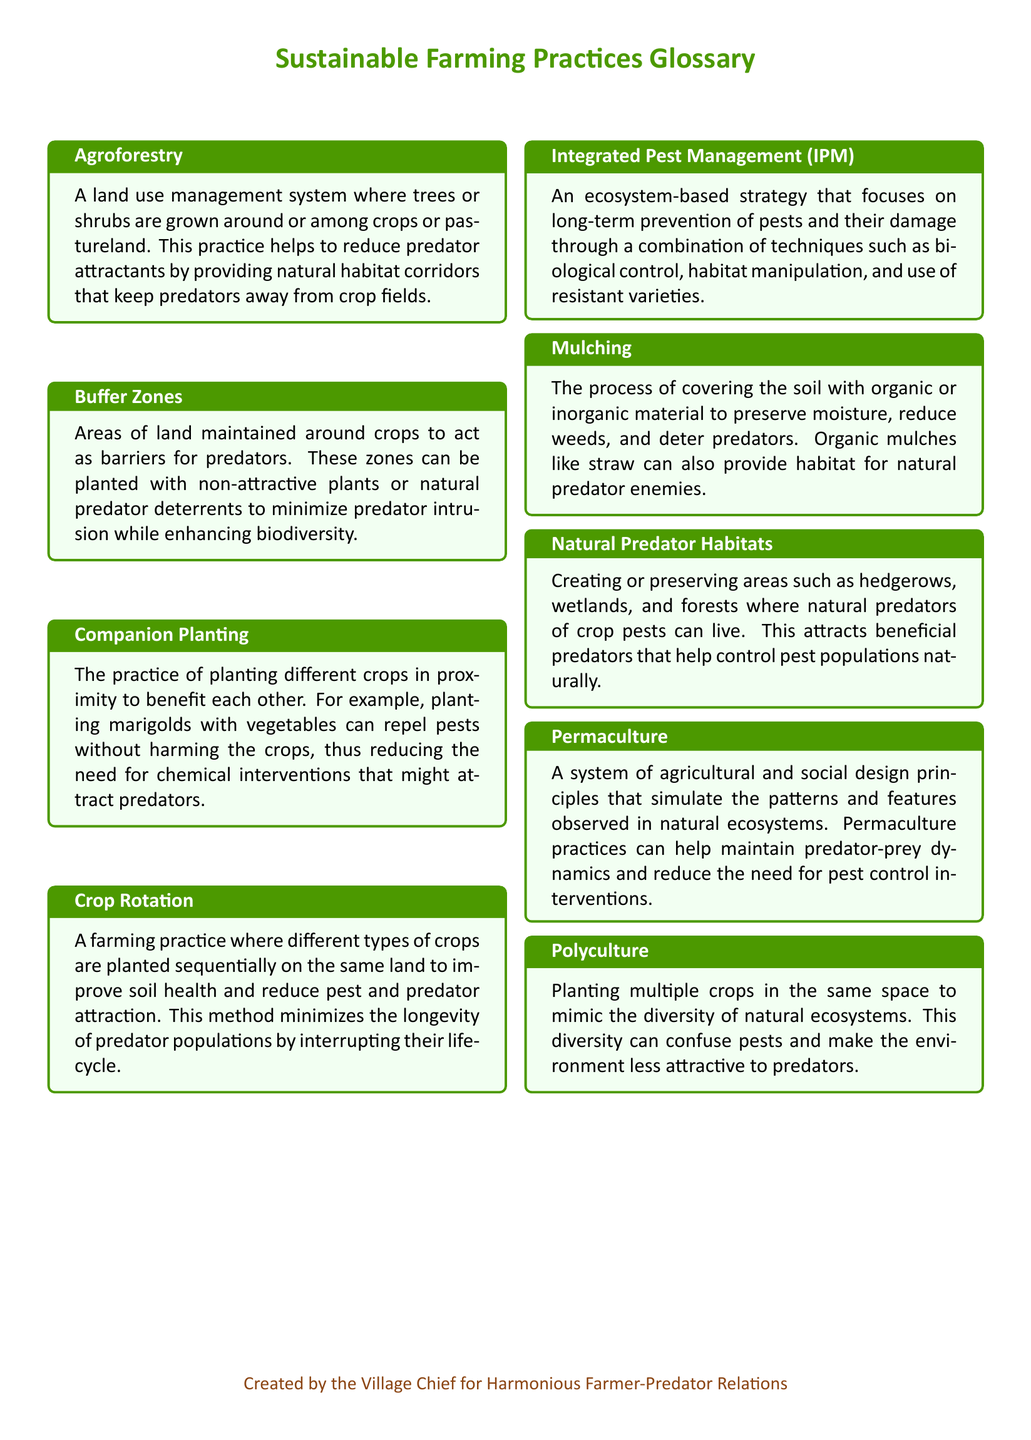What is Agroforestry? Agroforestry is defined in the document as a land use management system where trees or shrubs are grown around or among crops or pastureland.
Answer: A land use management system where trees or shrubs are grown around or among crops or pastureland What is the purpose of Buffer Zones? Buffer Zones are areas of land maintained around crops to act as barriers for predators, helping to minimize predator intrusion.
Answer: Act as barriers for predators What does Integrated Pest Management (IPM) focus on? IPM is an ecosystem-based strategy that focuses on the long-term prevention of pests and their damage through various techniques.
Answer: Long-term prevention of pests How do Companion Planting practices help in sustainable farming? Companion Planting involves planting different crops in proximity to benefit each other and repel pests, reducing the need for chemicals.
Answer: Repel pests without harming the crops What is the main benefit of creating Natural Predator Habitats? The document states that creating Natural Predator Habitats helps attract beneficial predators that control pest populations naturally.
Answer: Attract beneficial predators What does Polyculture mimic? Polyculture involves planting multiple crops in the same space to mimic the diversity of natural ecosystems.
Answer: The diversity of natural ecosystems How does Crop Rotation reduce predator attraction? Crop Rotation improves soil health and reduces pest and predator attraction by interrupting predator lifecycles.
Answer: Interrupting their lifecycle How can Mulching deter predators? Mulching covers the soil with material that can reduce weeds and deter predators, while organic mulches provide habitats for natural enemies.
Answer: Reduce weeds and deter predators 